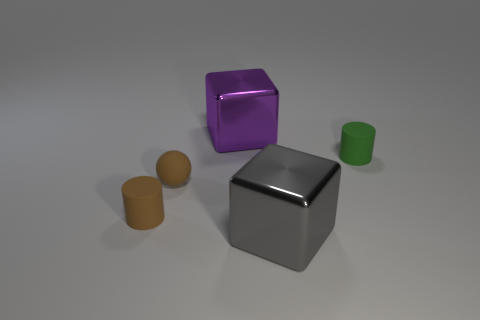Subtract 2 blocks. How many blocks are left? 0 Add 3 large gray cubes. How many objects exist? 8 Subtract all purple cubes. How many cubes are left? 1 Subtract all cubes. How many objects are left? 3 Subtract 0 brown blocks. How many objects are left? 5 Subtract all gray blocks. Subtract all blue spheres. How many blocks are left? 1 Subtract all gray cylinders. How many gray balls are left? 0 Subtract all big purple things. Subtract all small purple balls. How many objects are left? 4 Add 4 tiny cylinders. How many tiny cylinders are left? 6 Add 3 tiny cyan matte cubes. How many tiny cyan matte cubes exist? 3 